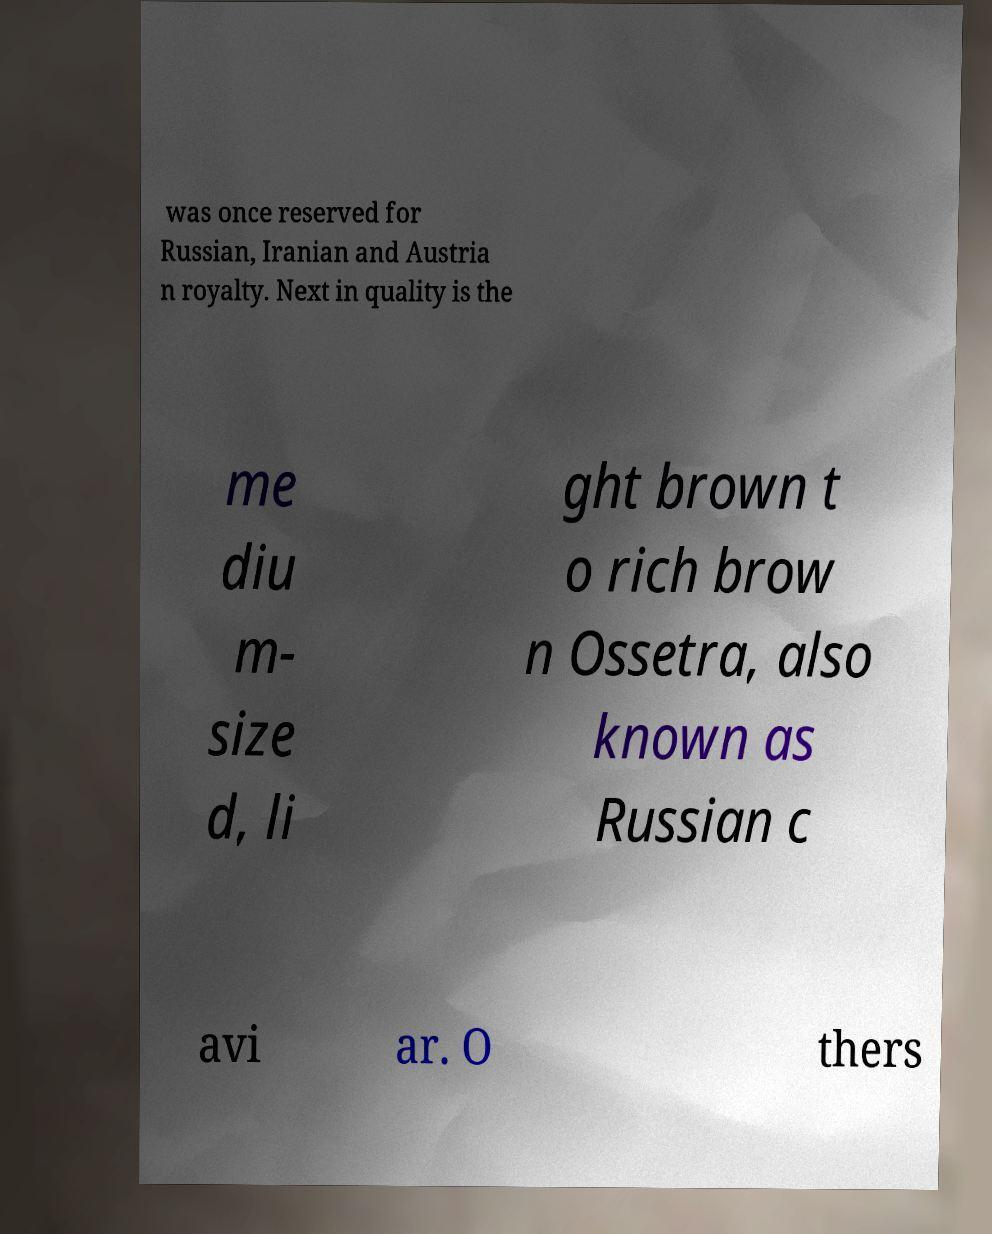Please identify and transcribe the text found in this image. was once reserved for Russian, Iranian and Austria n royalty. Next in quality is the me diu m- size d, li ght brown t o rich brow n Ossetra, also known as Russian c avi ar. O thers 